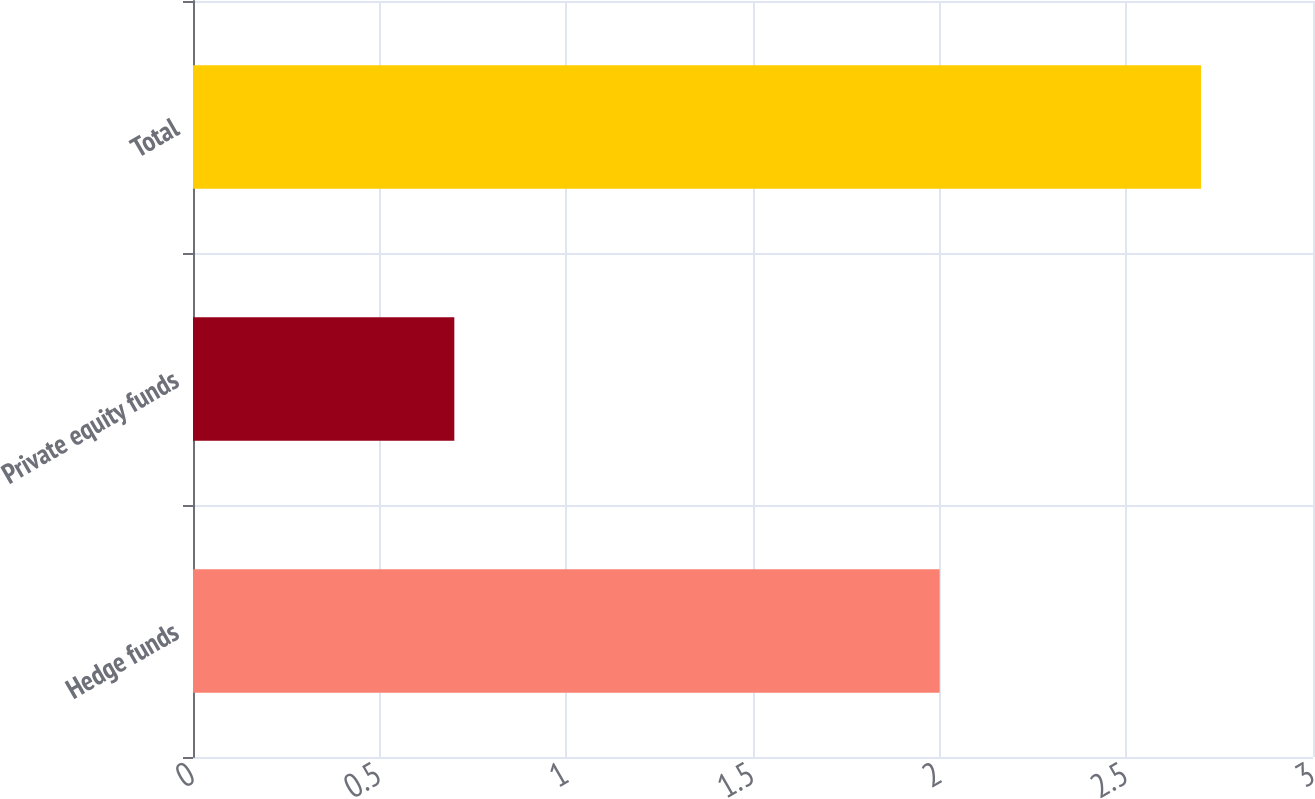Convert chart. <chart><loc_0><loc_0><loc_500><loc_500><bar_chart><fcel>Hedge funds<fcel>Private equity funds<fcel>Total<nl><fcel>2<fcel>0.7<fcel>2.7<nl></chart> 